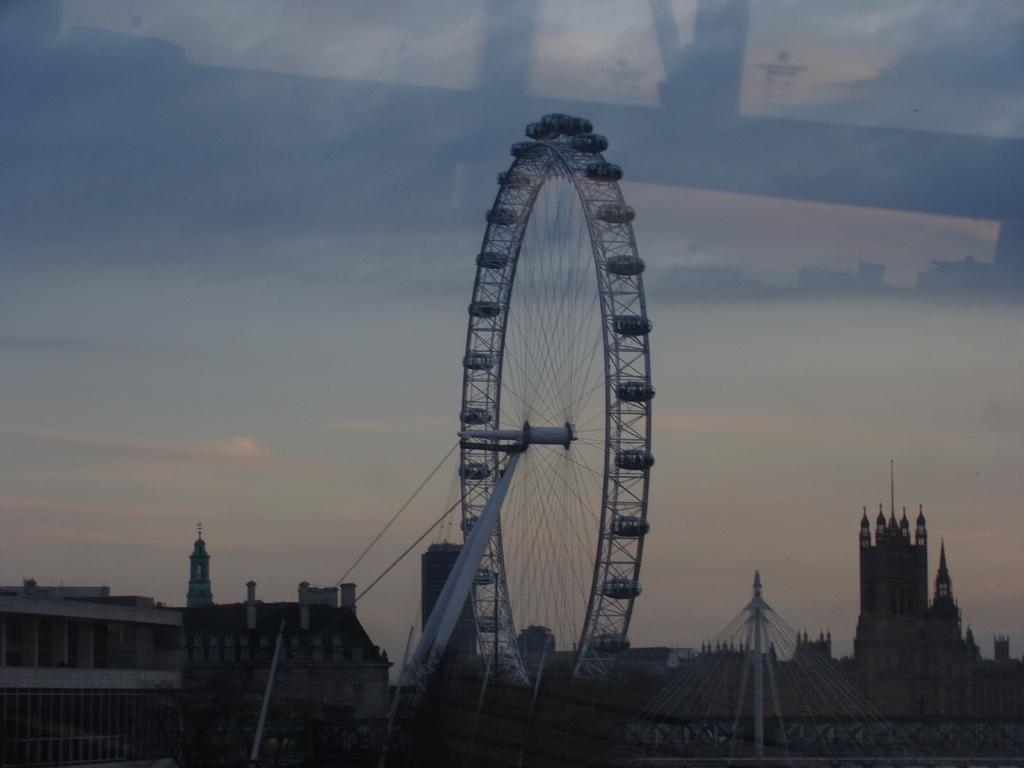What is the main subject in the center of the image? There is a giant wheel in the center of the image. What can be seen on either side of the giant wheel? There are buildings on either side of the giant wheel. What is visible at the top of the image? The sky is visible at the top of the image. Can you describe the acoustics of the cave in the image? There is no cave present in the image, so it is not possible to describe the acoustics. 